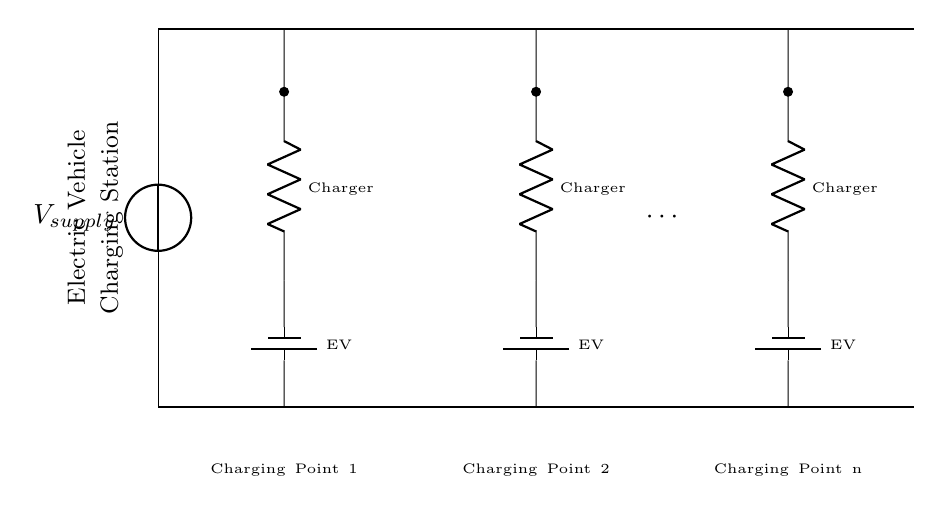What is the type of circuit shown? The circuit is organized to allow multiple devices to connect independently to the same power source without interfering with each other, indicating it is a parallel circuit.
Answer: Parallel circuit What are the main components used in this circuit? The diagram indicates that the main components are the voltage source, resistors (chargers), and electric vehicle batteries, all arranged in parallel.
Answer: Voltage source, resistors, batteries How many charging points are represented in the diagram? The diagram shows three explicit charging points, with an ellipsis indicating that more can be added, but only three are currently depicted as a complete dataset.
Answer: Three What is the purpose of the distribution bus in this circuit? The distribution bus serves as a central path through which power is distributed to multiple charging points simultaneously, demonstrating the parallel configuration's efficiency.
Answer: Power distribution If one charger is disconnected, how does this affect the other chargers? Since the chargers are arranged in parallel, disconnecting one charger does not affect the current flow to the others, allowing them to continue functioning independently.
Answer: No effect What is the role of the resistors in this circuit? The resistors represent the charging components that limit current to the electric vehicles, ensuring appropriate charging without overload, indicative of their role in current control.
Answer: Current limiting What is the significance of labeling the charging points? Labeling the charging points helps identify each individual connection to the power source, critical for management, maintenance, and operational clarity in a multi-vehicle charging scenario.
Answer: Identifying connections 